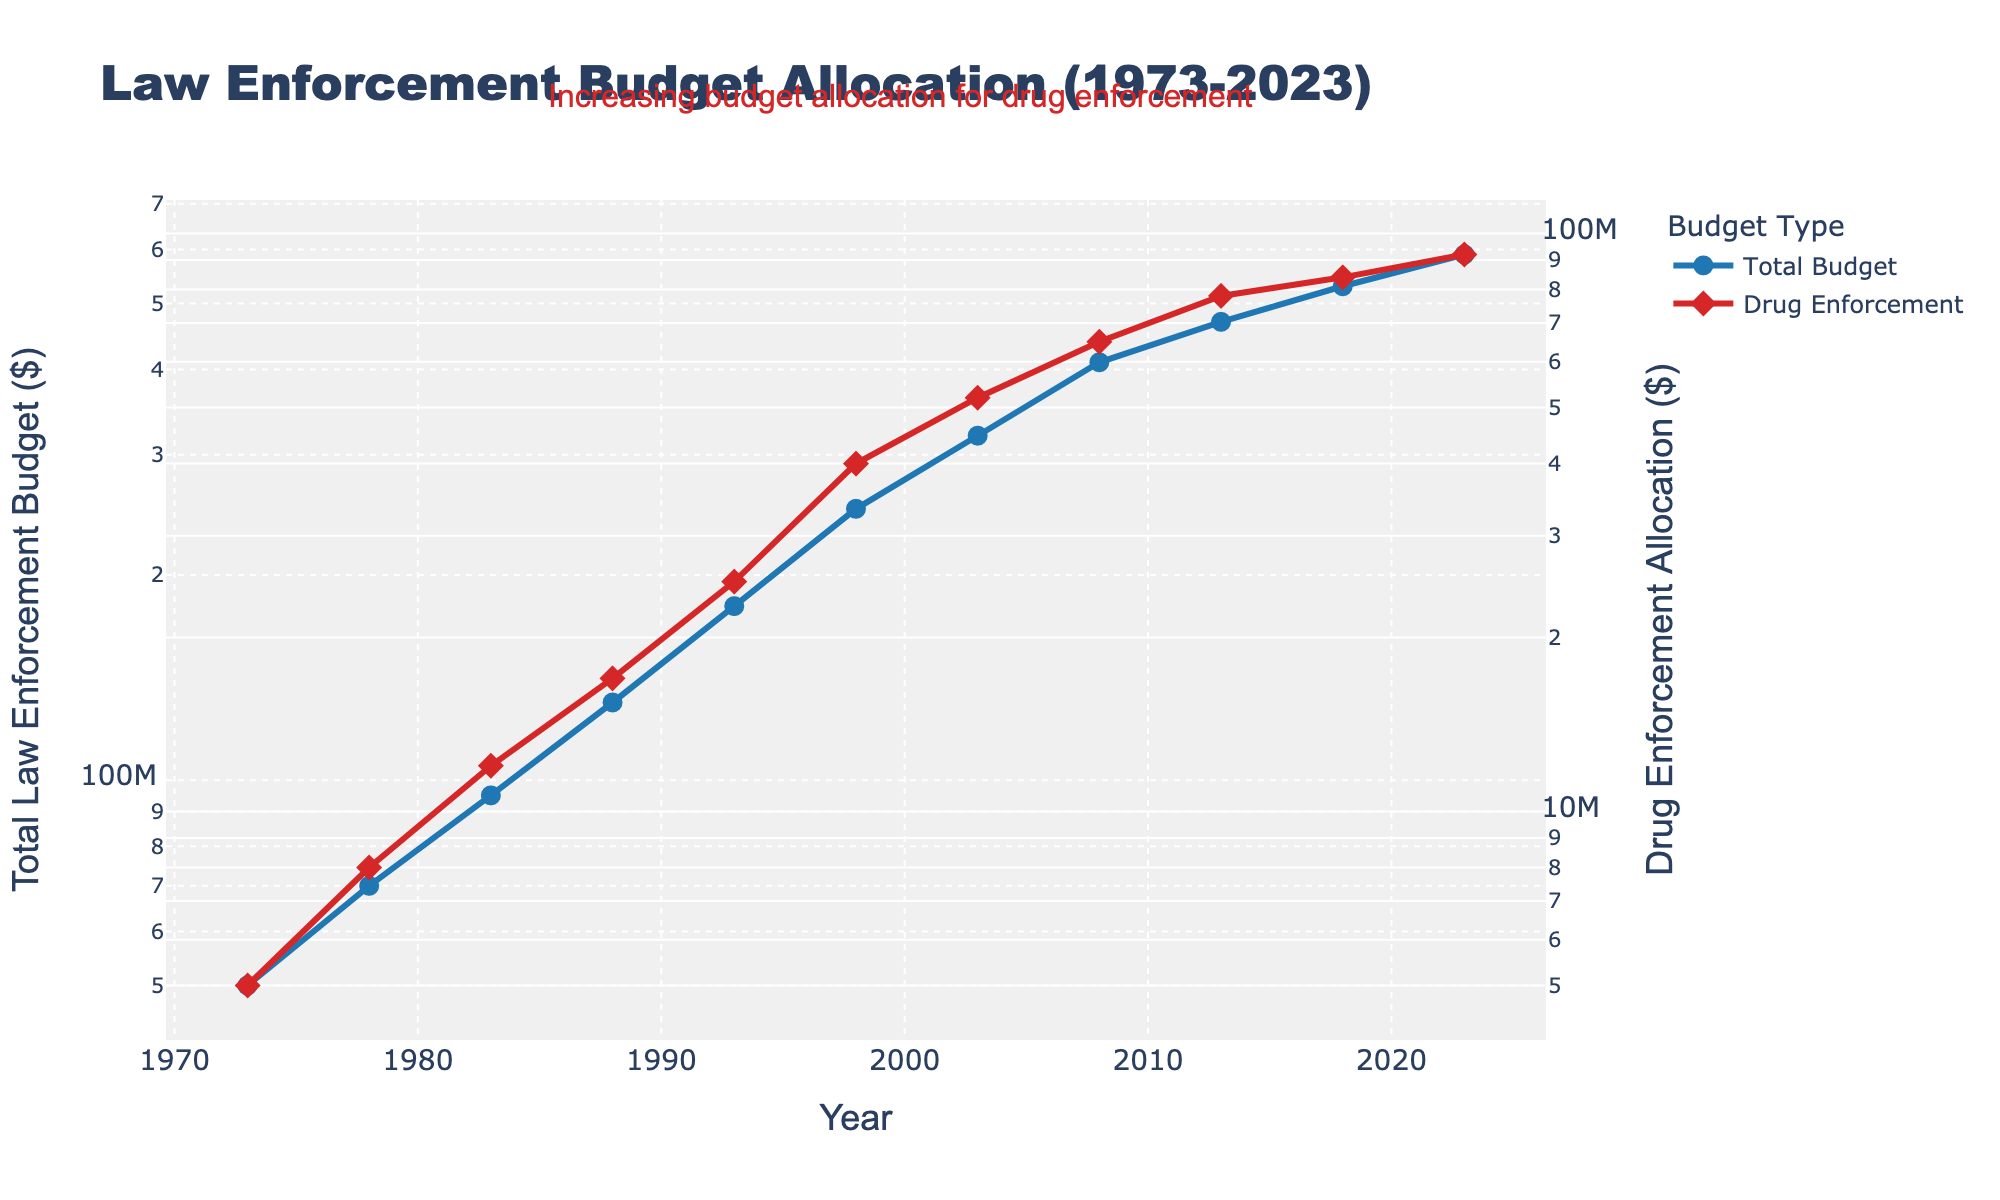What is the title of the plot? The title of the plot is usually positioned at the top of the figure. It is written in a larger and bold font to make it easily identifiable.
Answer: Law Enforcement Budget Allocation (1973-2023) What does the blue line represent in the figure? The blue line is one of the two lines in the plot, and it is labeled in the legend. By referring to the legend, it shows that the blue line represents the Total Budget.
Answer: Total Budget How much was allocated to drug enforcement in 1988? To find this, we locate the year 1988 on the x-axis and follow the red line (which represents Drug Enforcement) up to the corresponding y-axis value on the secondary y-axis.
Answer: $17,000,000 How did the Drug Enforcement Allocation change between 1993 and 2018? By examining the red line representing Drug Enforcement Allocation, note the values at 1993 and 2018. The value increased from $25,000,000 in 1993 to $84,000,000 in 2018.
Answer: It increased What is the overall trend of the Total Law Enforcement Budget from 1973 to 2023? By looking at the plot, we can see the blue line steadily rising from 1973 to 2023, indicating a consistent upward trend.
Answer: Upward trend What is the difference in Drug Enforcement Allocation between 1973 and 2023? To determine this, subtract the 1973 value ($5,000,000) from the 2023 value ($92,000,000).
Answer: $87,000,000 Which year shows the highest allocation to Drug Enforcement? By scanning the red line on the plot, the peak value occurs in 2023.
Answer: 2023 How does the growth rate of Drug Enforcement Allocation compare to the Total Law Enforcement Budget over this period? Both lines are increasing, but to compare growth rates, you can observe the slope or rate of increase. Drug Enforcement shows a steeper increase relatively, especially post 1990s.
Answer: Drug Enforcement allocation grew faster What is the annotation mentioned in the plot? The annotation is a text box that usually provides additional insights or commentary on the data. This plot has an annotation that states "Increasing budget allocation for drug enforcement", emphasizing the growth in this area.
Answer: Increasing budget allocation for drug enforcement What is the notable difference in visual scale between the y-axes? The plot uses a logarithmic scale for both y-axes, indicated by a consistent visual spacing despite increasing values, aiding in highlighting both lower and higher ranges effectively.
Answer: Both y-axes use a logarithmic scale 